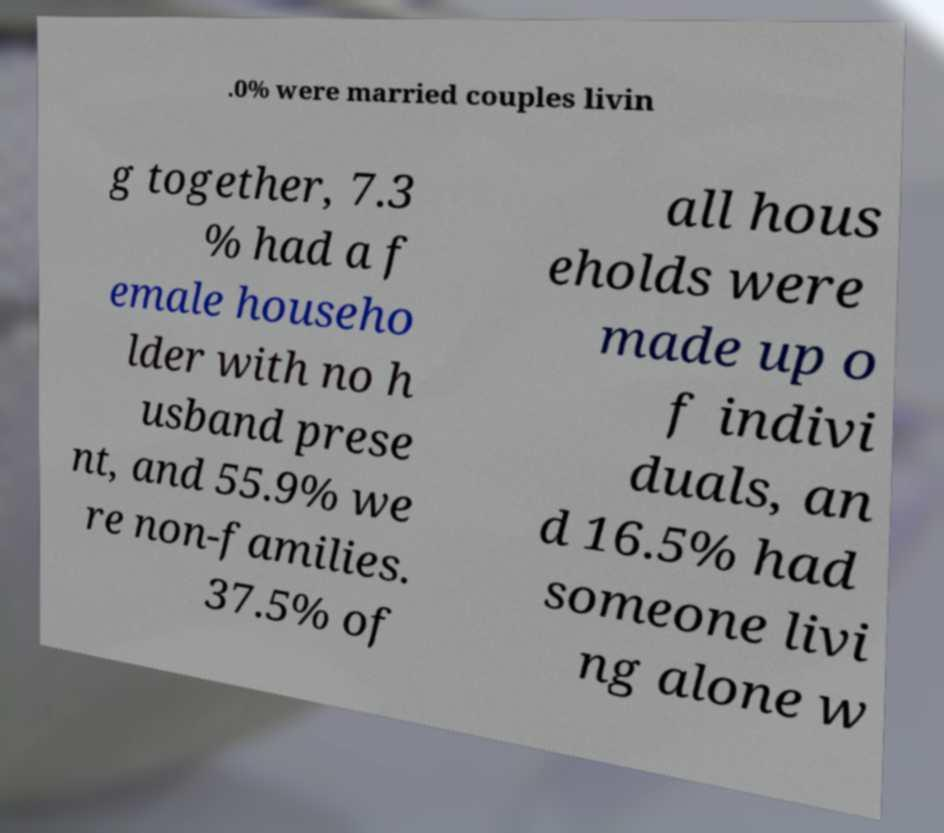Could you assist in decoding the text presented in this image and type it out clearly? .0% were married couples livin g together, 7.3 % had a f emale househo lder with no h usband prese nt, and 55.9% we re non-families. 37.5% of all hous eholds were made up o f indivi duals, an d 16.5% had someone livi ng alone w 